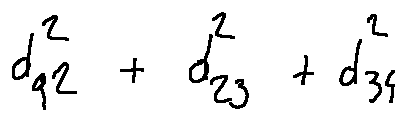<formula> <loc_0><loc_0><loc_500><loc_500>d _ { q 2 } ^ { 2 } + d _ { 2 3 } ^ { 2 } + d _ { 3 4 } ^ { 2 }</formula> 